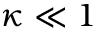<formula> <loc_0><loc_0><loc_500><loc_500>\kappa \ll 1</formula> 